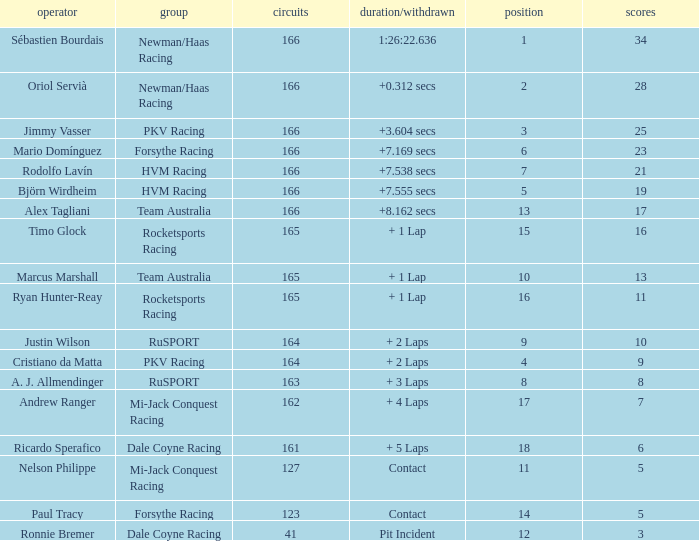What grid is the lowest when the time/retired is + 5 laps and the laps is less than 161? None. 